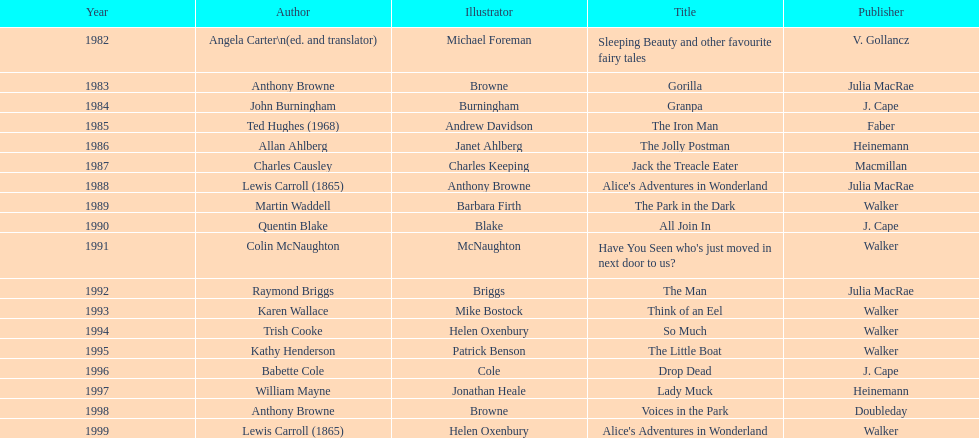What's the difference in years between angela carter's title and anthony browne's? 1. 